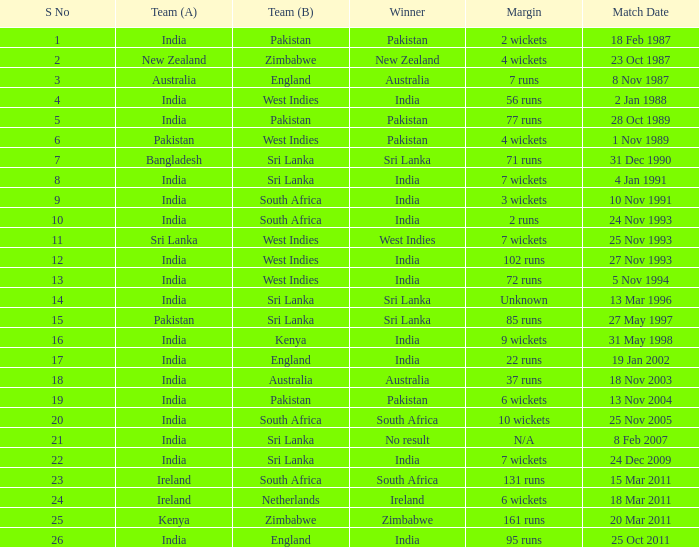What date did the West Indies win the match? 25 Nov 1993. 